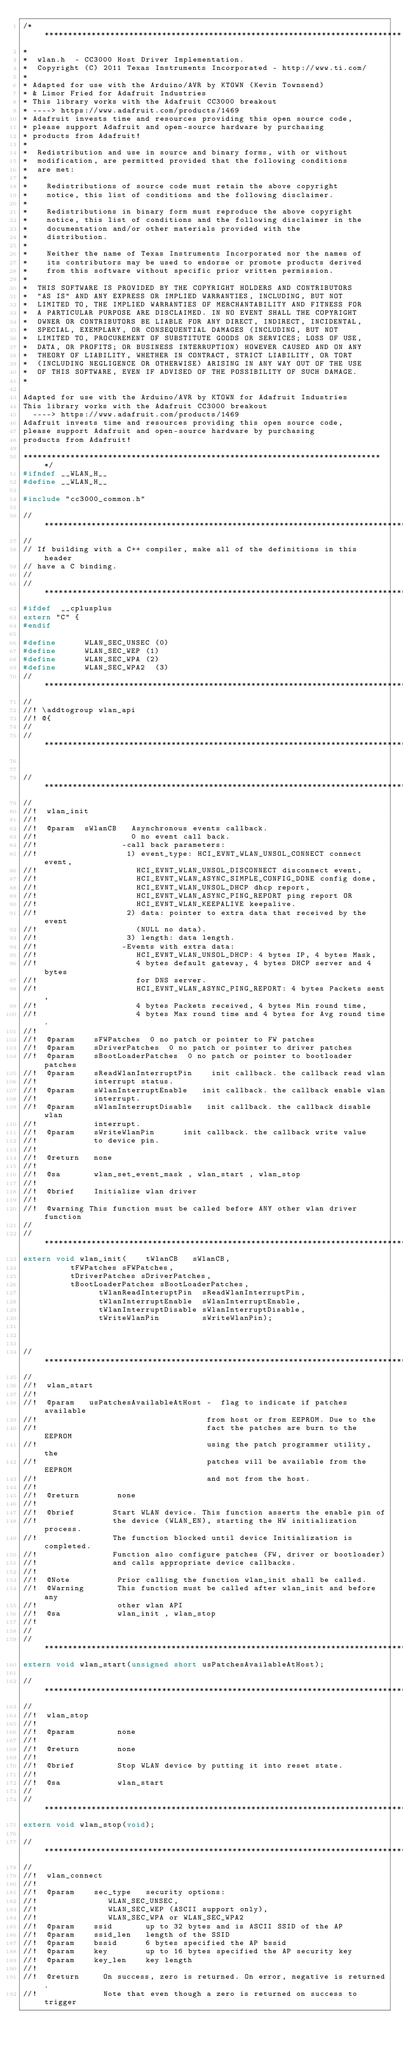Convert code to text. <code><loc_0><loc_0><loc_500><loc_500><_C_>/*****************************************************************************
*
*  wlan.h  - CC3000 Host Driver Implementation.
*  Copyright (C) 2011 Texas Instruments Incorporated - http://www.ti.com/
*
* Adapted for use with the Arduino/AVR by KTOWN (Kevin Townsend) 
* & Limor Fried for Adafruit Industries
* This library works with the Adafruit CC3000 breakout 
*	----> https://www.adafruit.com/products/1469
* Adafruit invests time and resources providing this open source code,
* please support Adafruit and open-source hardware by purchasing
* products from Adafruit!
*
*  Redistribution and use in source and binary forms, with or without
*  modification, are permitted provided that the following conditions
*  are met:
*
*    Redistributions of source code must retain the above copyright
*    notice, this list of conditions and the following disclaimer.
*
*    Redistributions in binary form must reproduce the above copyright
*    notice, this list of conditions and the following disclaimer in the
*    documentation and/or other materials provided with the   
*    distribution.
*
*    Neither the name of Texas Instruments Incorporated nor the names of
*    its contributors may be used to endorse or promote products derived
*    from this software without specific prior written permission.
*
*  THIS SOFTWARE IS PROVIDED BY THE COPYRIGHT HOLDERS AND CONTRIBUTORS 
*  "AS IS" AND ANY EXPRESS OR IMPLIED WARRANTIES, INCLUDING, BUT NOT 
*  LIMITED TO, THE IMPLIED WARRANTIES OF MERCHANTABILITY AND FITNESS FOR
*  A PARTICULAR PURPOSE ARE DISCLAIMED. IN NO EVENT SHALL THE COPYRIGHT 
*  OWNER OR CONTRIBUTORS BE LIABLE FOR ANY DIRECT, INDIRECT, INCIDENTAL, 
*  SPECIAL, EXEMPLARY, OR CONSEQUENTIAL DAMAGES (INCLUDING, BUT NOT 
*  LIMITED TO, PROCUREMENT OF SUBSTITUTE GOODS OR SERVICES; LOSS OF USE,
*  DATA, OR PROFITS; OR BUSINESS INTERRUPTION) HOWEVER CAUSED AND ON ANY
*  THEORY OF LIABILITY, WHETHER IN CONTRACT, STRICT LIABILITY, OR TORT 
*  (INCLUDING NEGLIGENCE OR OTHERWISE) ARISING IN ANY WAY OUT OF THE USE 
*  OF THIS SOFTWARE, EVEN IF ADVISED OF THE POSSIBILITY OF SUCH DAMAGE.
*

Adapted for use with the Arduino/AVR by KTOWN for Adafruit Industries
This library works with the Adafruit CC3000 breakout 
	----> https://www.adafruit.com/products/1469
Adafruit invests time and resources providing this open source code,
please support Adafruit and open-source hardware by purchasing
products from Adafruit!

*****************************************************************************/
#ifndef __WLAN_H__
#define	__WLAN_H__

#include "cc3000_common.h"

//*****************************************************************************
//
// If building with a C++ compiler, make all of the definitions in this header
// have a C binding.
//
//*****************************************************************************
#ifdef	__cplusplus
extern "C" {
#endif

#define      WLAN_SEC_UNSEC (0)
#define      WLAN_SEC_WEP	(1)
#define      WLAN_SEC_WPA	(2)
#define      WLAN_SEC_WPA2	(3)
//*****************************************************************************
//
//! \addtogroup wlan_api
//! @{
//
//*****************************************************************************


//*****************************************************************************
//
//!  wlan_init
//!
//!  @param  sWlanCB   Asynchronous events callback.  
//!                    0 no event call back.
//!                  -call back parameters:
//!                   1) event_type: HCI_EVNT_WLAN_UNSOL_CONNECT connect event,
//!                     HCI_EVNT_WLAN_UNSOL_DISCONNECT disconnect event,
//!                     HCI_EVNT_WLAN_ASYNC_SIMPLE_CONFIG_DONE config done,
//!                     HCI_EVNT_WLAN_UNSOL_DHCP dhcp report, 
//!                     HCI_EVNT_WLAN_ASYNC_PING_REPORT ping report OR 
//!                     HCI_EVNT_WLAN_KEEPALIVE keepalive.
//!                   2) data: pointer to extra data that received by the event
//!                     (NULL no data).
//!                   3) length: data length.
//!                  -Events with extra data:
//!                     HCI_EVNT_WLAN_UNSOL_DHCP: 4 bytes IP, 4 bytes Mask, 
//!                     4 bytes default gateway, 4 bytes DHCP server and 4 bytes
//!                     for DNS server.
//!                     HCI_EVNT_WLAN_ASYNC_PING_REPORT: 4 bytes Packets sent, 
//!                     4 bytes Packets received, 4 bytes Min round time, 
//!                     4 bytes Max round time and 4 bytes for Avg round time.
//!
//!  @param    sFWPatches  0 no patch or pointer to FW patches 
//!  @param    sDriverPatches  0 no patch or pointer to driver patches
//!  @param    sBootLoaderPatches  0 no patch or pointer to bootloader patches
//!  @param    sReadWlanInterruptPin    init callback. the callback read wlan 
//!            interrupt status.
//!  @param    sWlanInterruptEnable   init callback. the callback enable wlan 
//!            interrupt.
//!  @param    sWlanInterruptDisable   init callback. the callback disable wlan
//!            interrupt.
//!  @param    sWriteWlanPin      init callback. the callback write value 
//!            to device pin.  
//!
//!  @return   none
//!
//!  @sa       wlan_set_event_mask , wlan_start , wlan_stop 
//!
//!  @brief    Initialize wlan driver
//!
//!  @warning This function must be called before ANY other wlan driver function
//
//*****************************************************************************
extern void wlan_init(		tWlanCB	 	sWlanCB,
	   			tFWPatches sFWPatches,
	   			tDriverPatches sDriverPatches,
	   			tBootLoaderPatches sBootLoaderPatches,
                tWlanReadInteruptPin  sReadWlanInterruptPin,
                tWlanInterruptEnable  sWlanInterruptEnable,
                tWlanInterruptDisable sWlanInterruptDisable,
                tWriteWlanPin         sWriteWlanPin);



//*****************************************************************************
//
//!  wlan_start
//!
//!  @param   usPatchesAvailableAtHost -  flag to indicate if patches available
//!                                    from host or from EEPROM. Due to the 
//!                                    fact the patches are burn to the EEPROM
//!                                    using the patch programmer utility, the 
//!                                    patches will be available from the EEPROM
//!                                    and not from the host.
//!
//!  @return        none
//!
//!  @brief        Start WLAN device. This function asserts the enable pin of 
//!                the device (WLAN_EN), starting the HW initialization process.
//!                The function blocked until device Initialization is completed.
//!                Function also configure patches (FW, driver or bootloader) 
//!                and calls appropriate device callbacks.
//!
//!  @Note          Prior calling the function wlan_init shall be called.
//!  @Warning       This function must be called after wlan_init and before any 
//!                 other wlan API
//!  @sa            wlan_init , wlan_stop
//!
//
//*****************************************************************************
extern void wlan_start(unsigned short usPatchesAvailableAtHost);

//*****************************************************************************
//
//!  wlan_stop
//!
//!  @param         none
//!
//!  @return        none
//!
//!  @brief         Stop WLAN device by putting it into reset state.
//!
//!  @sa            wlan_start
//
//*****************************************************************************
extern void wlan_stop(void);

//*****************************************************************************
//
//!  wlan_connect
//!
//!  @param    sec_type   security options:
//!               WLAN_SEC_UNSEC, 
//!               WLAN_SEC_WEP (ASCII support only),
//!               WLAN_SEC_WPA or WLAN_SEC_WPA2
//!  @param    ssid       up to 32 bytes and is ASCII SSID of the AP
//!  @param    ssid_len   length of the SSID
//!  @param    bssid      6 bytes specified the AP bssid
//!  @param    key        up to 16 bytes specified the AP security key
//!  @param    key_len    key length 
//!
//!  @return     On success, zero is returned. On error, negative is returned. 
//!              Note that even though a zero is returned on success to trigger</code> 